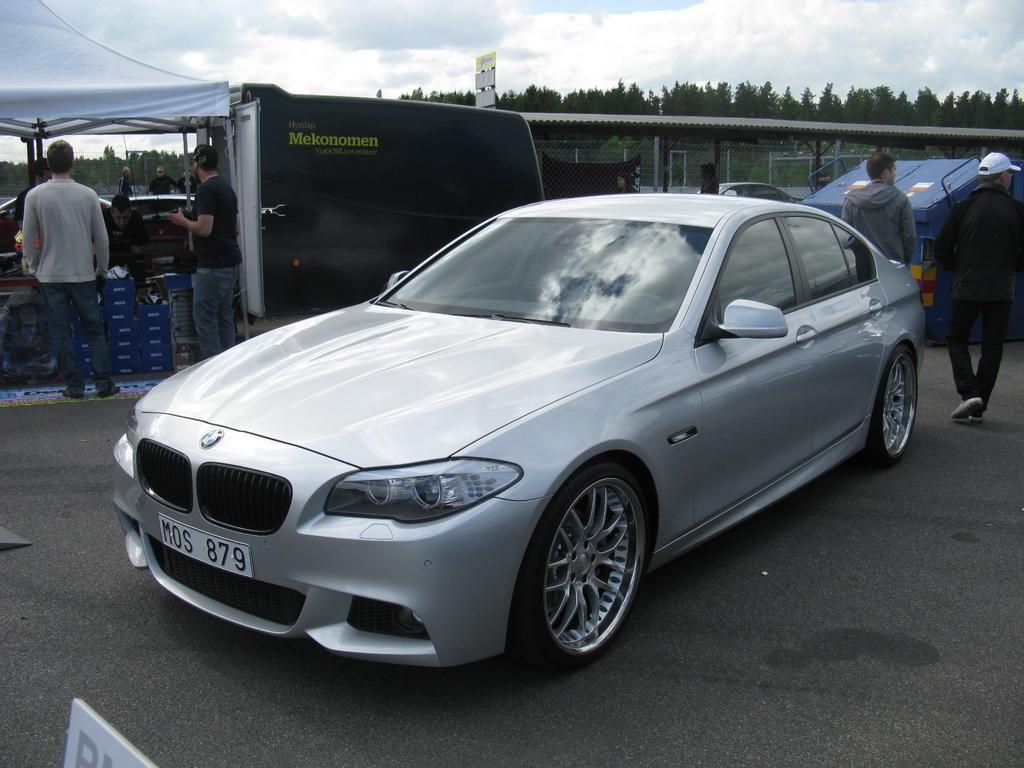What is the main object in the image? There is a car in the image. What else can be seen in the image besides the car? There is a tent and people in the image. What is visible in the background of the image? There are trees and a cloudy sky in the background of the image. What is written on the board in the image? There is a board with something written on it in the image. Where is the shelf located in the image? There is no shelf present in the image. What is the mother doing in the image? There is no mention of a mother or her actions in the image. 